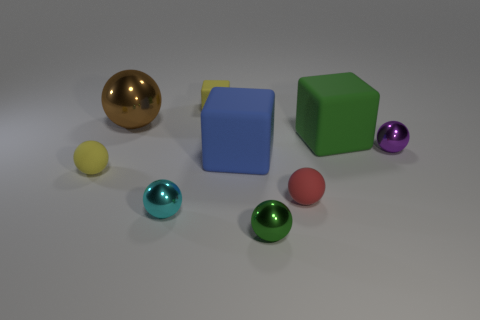Subtract all small yellow balls. How many balls are left? 5 Subtract all yellow blocks. How many blocks are left? 2 Subtract all blocks. How many objects are left? 6 Subtract 0 blue balls. How many objects are left? 9 Subtract 1 blocks. How many blocks are left? 2 Subtract all yellow blocks. Subtract all yellow balls. How many blocks are left? 2 Subtract all gray spheres. How many green blocks are left? 1 Subtract all big green metal spheres. Subtract all small green metallic balls. How many objects are left? 8 Add 8 brown balls. How many brown balls are left? 9 Add 8 purple metal blocks. How many purple metal blocks exist? 8 